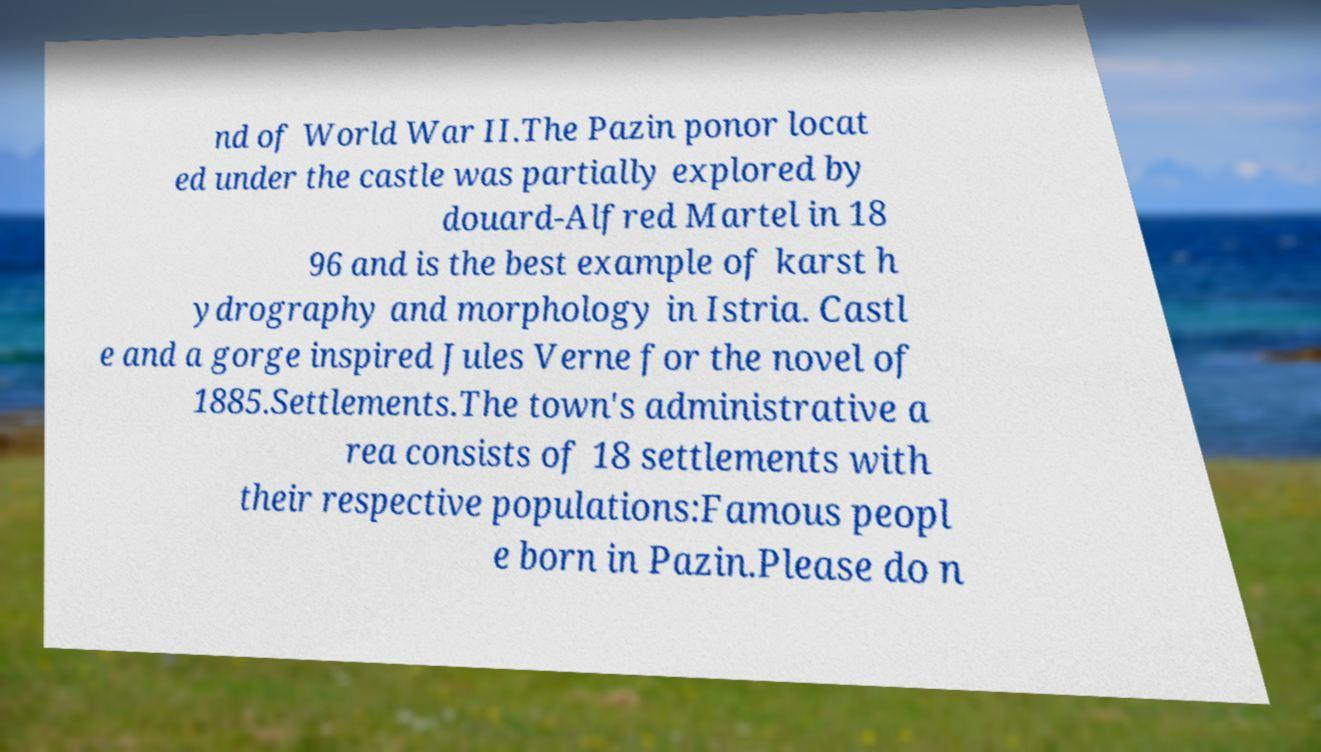Please read and relay the text visible in this image. What does it say? nd of World War II.The Pazin ponor locat ed under the castle was partially explored by douard-Alfred Martel in 18 96 and is the best example of karst h ydrography and morphology in Istria. Castl e and a gorge inspired Jules Verne for the novel of 1885.Settlements.The town's administrative a rea consists of 18 settlements with their respective populations:Famous peopl e born in Pazin.Please do n 